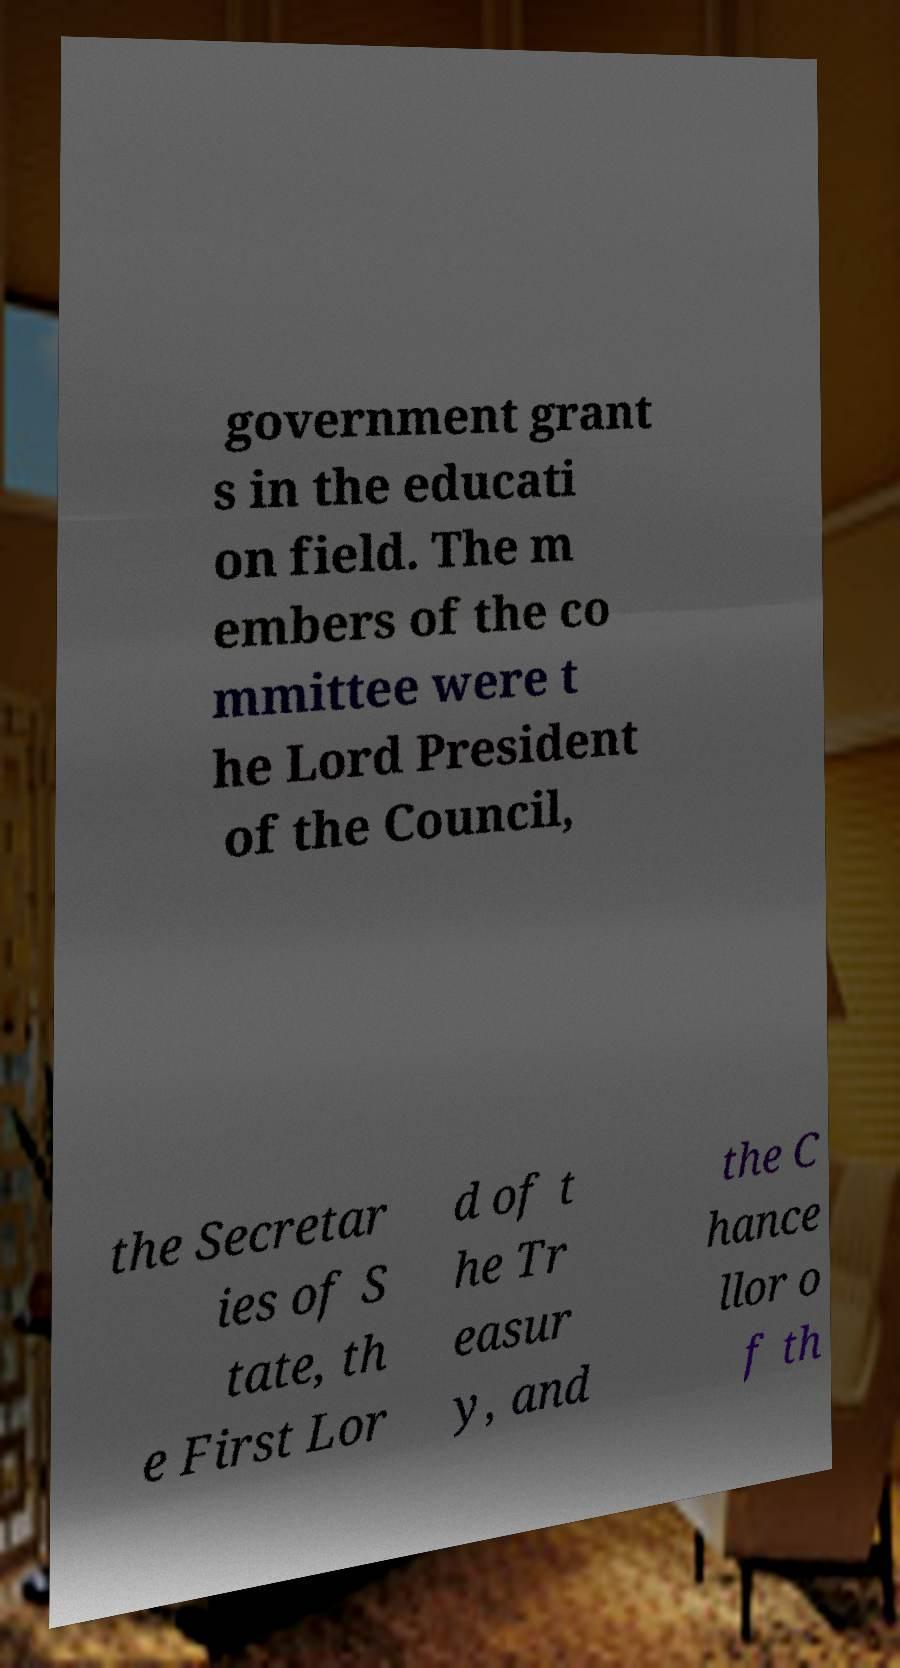Can you read and provide the text displayed in the image?This photo seems to have some interesting text. Can you extract and type it out for me? government grant s in the educati on field. The m embers of the co mmittee were t he Lord President of the Council, the Secretar ies of S tate, th e First Lor d of t he Tr easur y, and the C hance llor o f th 